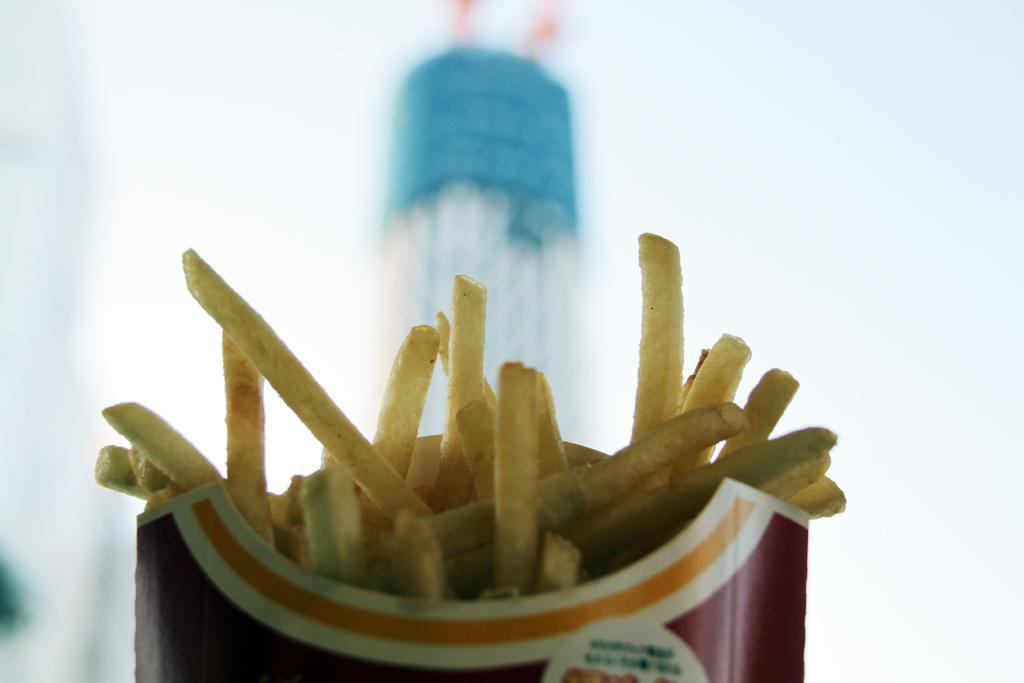Could you give a brief overview of what you see in this image? As we can see in the image there is a box. In box there is french fries and the background is blurred. 